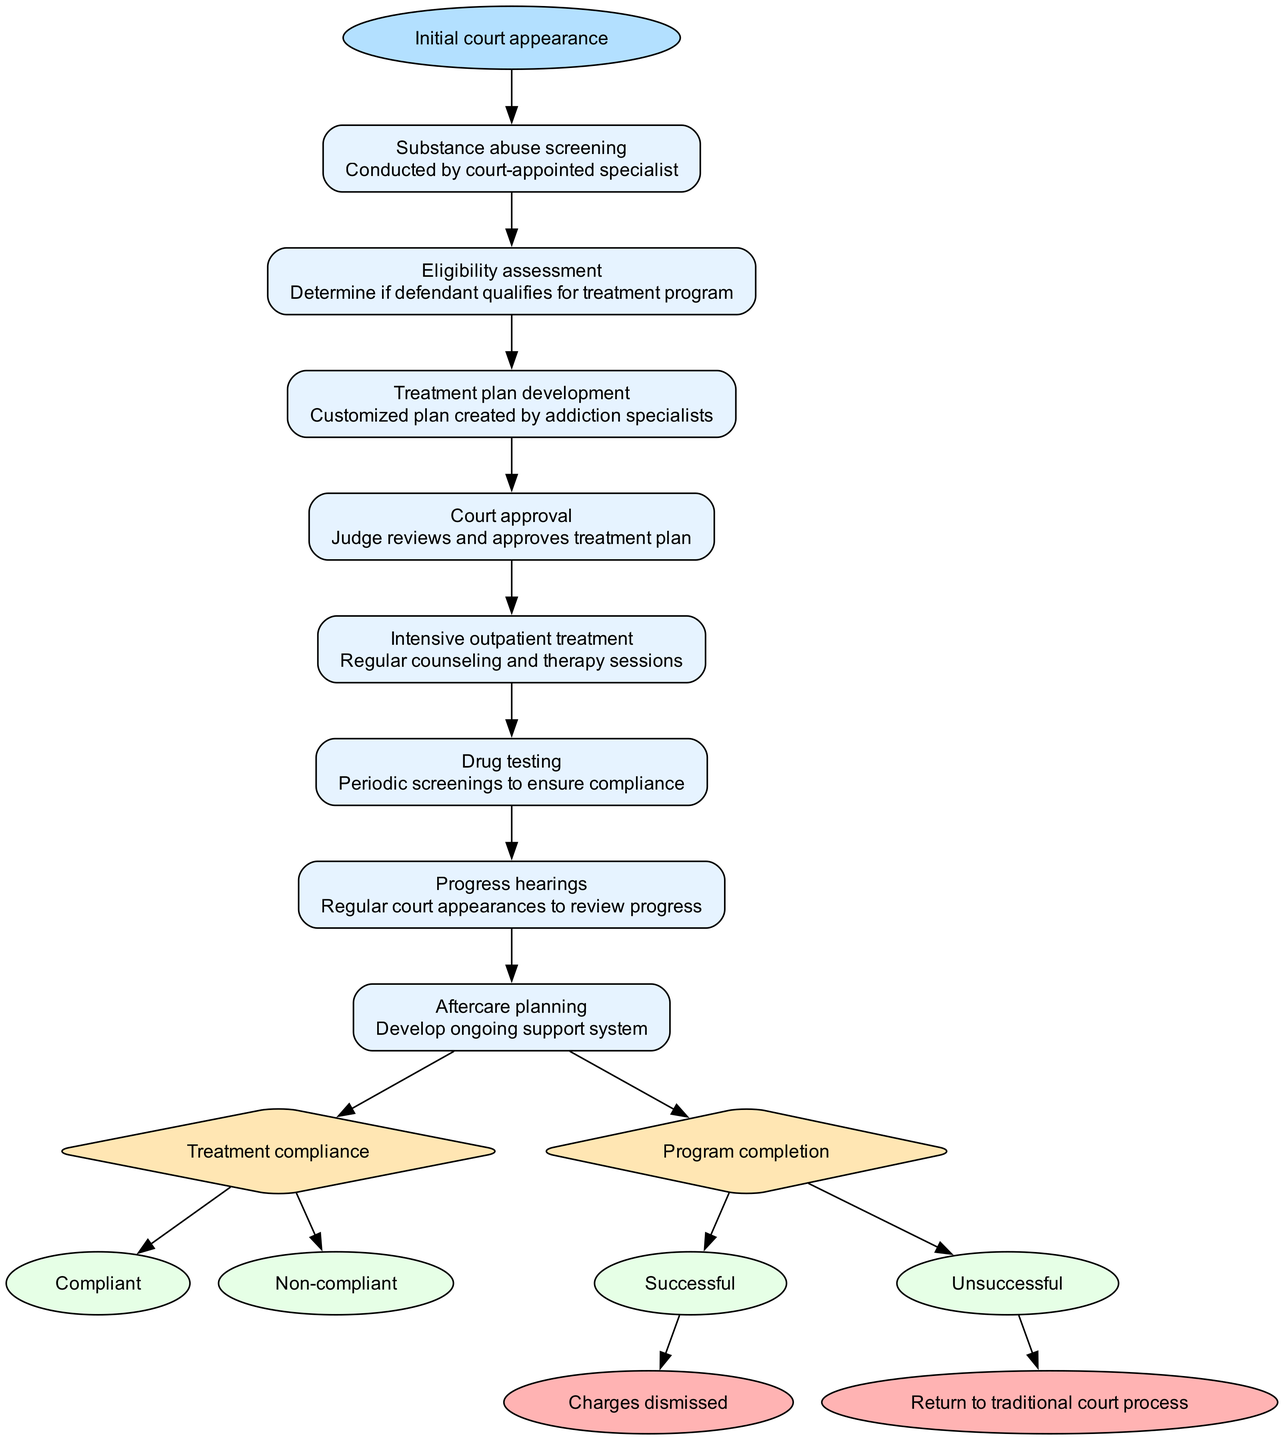What is the starting point of the clinical pathway? The starting point, as indicated in the diagram, is the "Initial court appearance". This is the very first step before proceeding to substance abuse screening.
Answer: Initial court appearance How many steps are included in the clinical pathway? By counting the steps listed in the diagram, there are a total of eight steps outlined in the pathway.
Answer: 8 What is the last step before a decision point in the clinical pathway? The last step before any decision point in the pathway is "Progress hearings". It follows intensive outpatient treatment and precedes the decision-making regarding treatment compliance.
Answer: Progress hearings What are the two options for the treatment compliance decision point? The diagram provides two options for the treatment compliance decision point, which are "Compliant" and "Non-compliant". These options indicate whether the defendant is adhering to the treatment plan.
Answer: Compliant, Non-compliant What happens if a defendant is successful in completing the program? If a defendant completes the program successfully, the pathway indicates the outcome as "Charges dismissed". This suggests that successful completion leads to a positive resolution for the defendant.
Answer: Charges dismissed Which step involves creating a customized plan? The step that involves creating a customized plan is "Treatment plan development". This is where addiction specialists develop an individualized treatment strategy for the defendant.
Answer: Treatment plan development What is the purpose of drug testing in the pathway? The purpose of drug testing in the pathway, as outlined, is to ensure compliance during the treatment phase. This step involves periodic screenings to check if the defendant is following the program correctly.
Answer: Ensure compliance What is the alternative outcome if a defendant is non-compliant with the treatment? If the defendant is non-compliant, the alternative outcome in the pathway is "Return to traditional court process". This indicates that failing to comply may result in reverting to regular judicial proceedings.
Answer: Return to traditional court process How many end points are outlined in the clinical pathway? The clinical pathway outlines two end points, which are "Charges dismissed" and "Return to traditional court process". This number indicates the potential outcomes based on the defendant's progress.
Answer: 2 